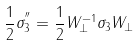Convert formula to latex. <formula><loc_0><loc_0><loc_500><loc_500>\frac { 1 } { 2 } \sigma _ { 3 } ^ { ^ { \prime \prime } } = \frac { 1 } { 2 } W _ { \perp } ^ { - 1 } \sigma _ { 3 } W _ { \perp }</formula> 